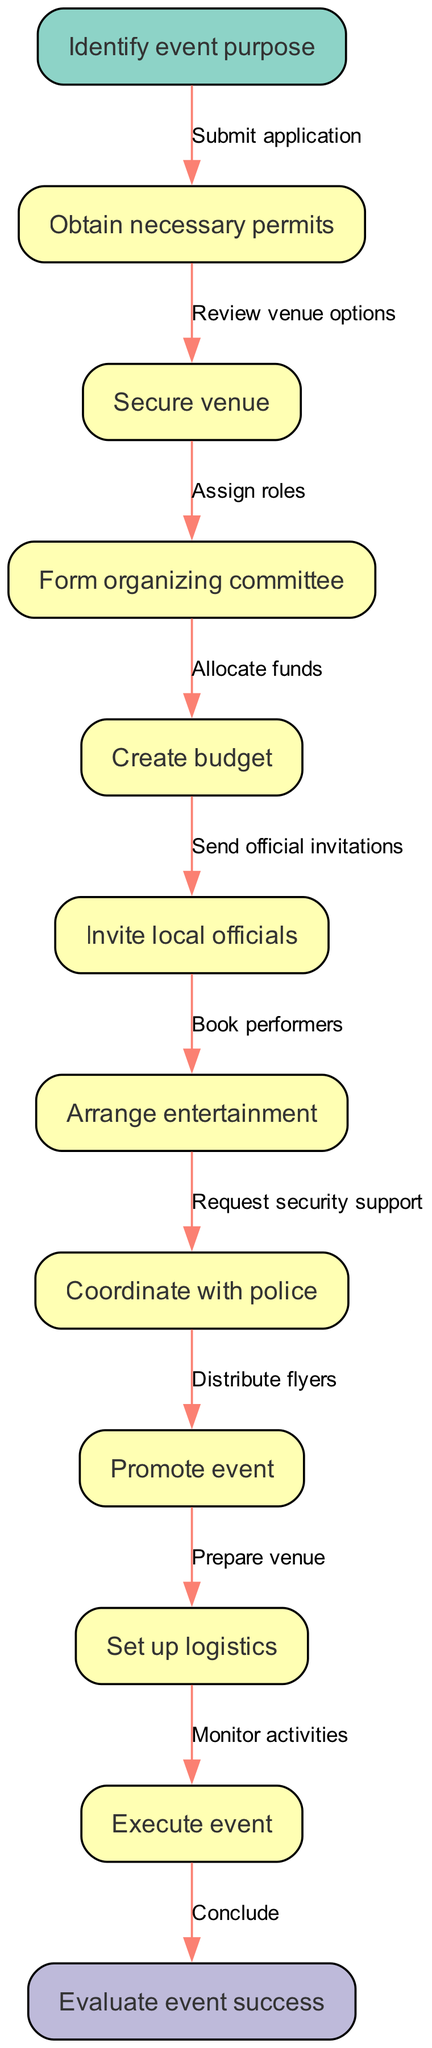What is the first step in the process? The diagram starts with the node labeled "Identify event purpose," which indicates it is the first step in organizing the local community event.
Answer: Identify event purpose How many total nodes are present in the diagram? The diagram includes one start node, ten process nodes, and one end node, totaling twelve nodes.
Answer: Twelve What is the last step before concluding the event? The final process node before the end node is labeled "Monitor activities," which is the last step taken before concluding the event.
Answer: Monitor activities Which node directly follows the "Create budget" node? The node labeled "Invite local officials" is the next step that directly follows the "Create budget" node as per the flow of the diagram.
Answer: Invite local officials How many edges are there in total connecting the nodes? There are eleven edges in total, connecting one start node to ten process nodes and linking to one end node, making a total of eleven connections.
Answer: Eleven What type of permits must be obtained in the process? The diagram specifies "Obtain necessary permits" as a primary step, indicating that necessary permits relevant to the event organization must be secured.
Answer: Necessary permits What action is taken after "Arrange entertainment"? The subsequent step indicated in the diagram after "Arrange entertainment" is "Coordinate with police," indicating a need for communication with local law enforcement.
Answer: Coordinate with police Which two nodes are directly connected to "Promote event"? The node "Promote event" is directly connected to "Arrange entertainment" before it and "Set up logistics" after it, indicating it is in the middle of these two processes.
Answer: Arrange entertainment, Set up logistics What color represents the start node in the diagram? The start node is filled with a color code that corresponds to a soft green shade, which is visually indicated by the hex color code used in the diagram design.
Answer: Soft green 